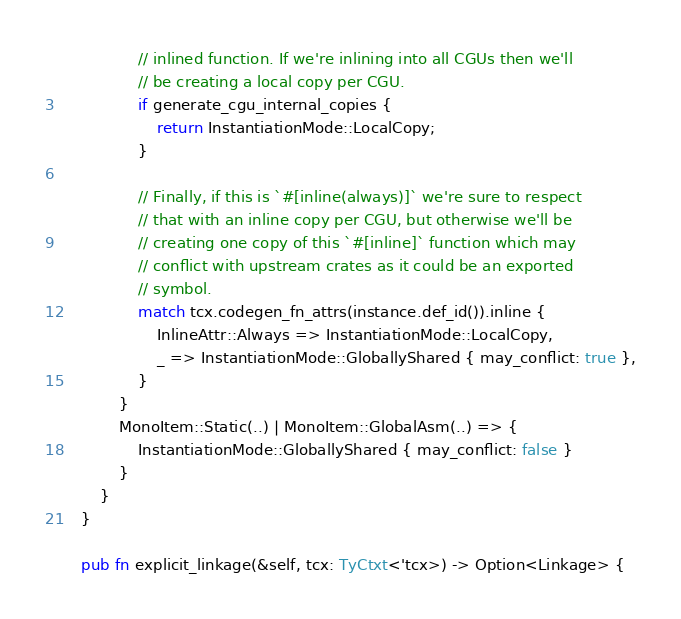Convert code to text. <code><loc_0><loc_0><loc_500><loc_500><_Rust_>                // inlined function. If we're inlining into all CGUs then we'll
                // be creating a local copy per CGU.
                if generate_cgu_internal_copies {
                    return InstantiationMode::LocalCopy;
                }

                // Finally, if this is `#[inline(always)]` we're sure to respect
                // that with an inline copy per CGU, but otherwise we'll be
                // creating one copy of this `#[inline]` function which may
                // conflict with upstream crates as it could be an exported
                // symbol.
                match tcx.codegen_fn_attrs(instance.def_id()).inline {
                    InlineAttr::Always => InstantiationMode::LocalCopy,
                    _ => InstantiationMode::GloballyShared { may_conflict: true },
                }
            }
            MonoItem::Static(..) | MonoItem::GlobalAsm(..) => {
                InstantiationMode::GloballyShared { may_conflict: false }
            }
        }
    }

    pub fn explicit_linkage(&self, tcx: TyCtxt<'tcx>) -> Option<Linkage> {</code> 